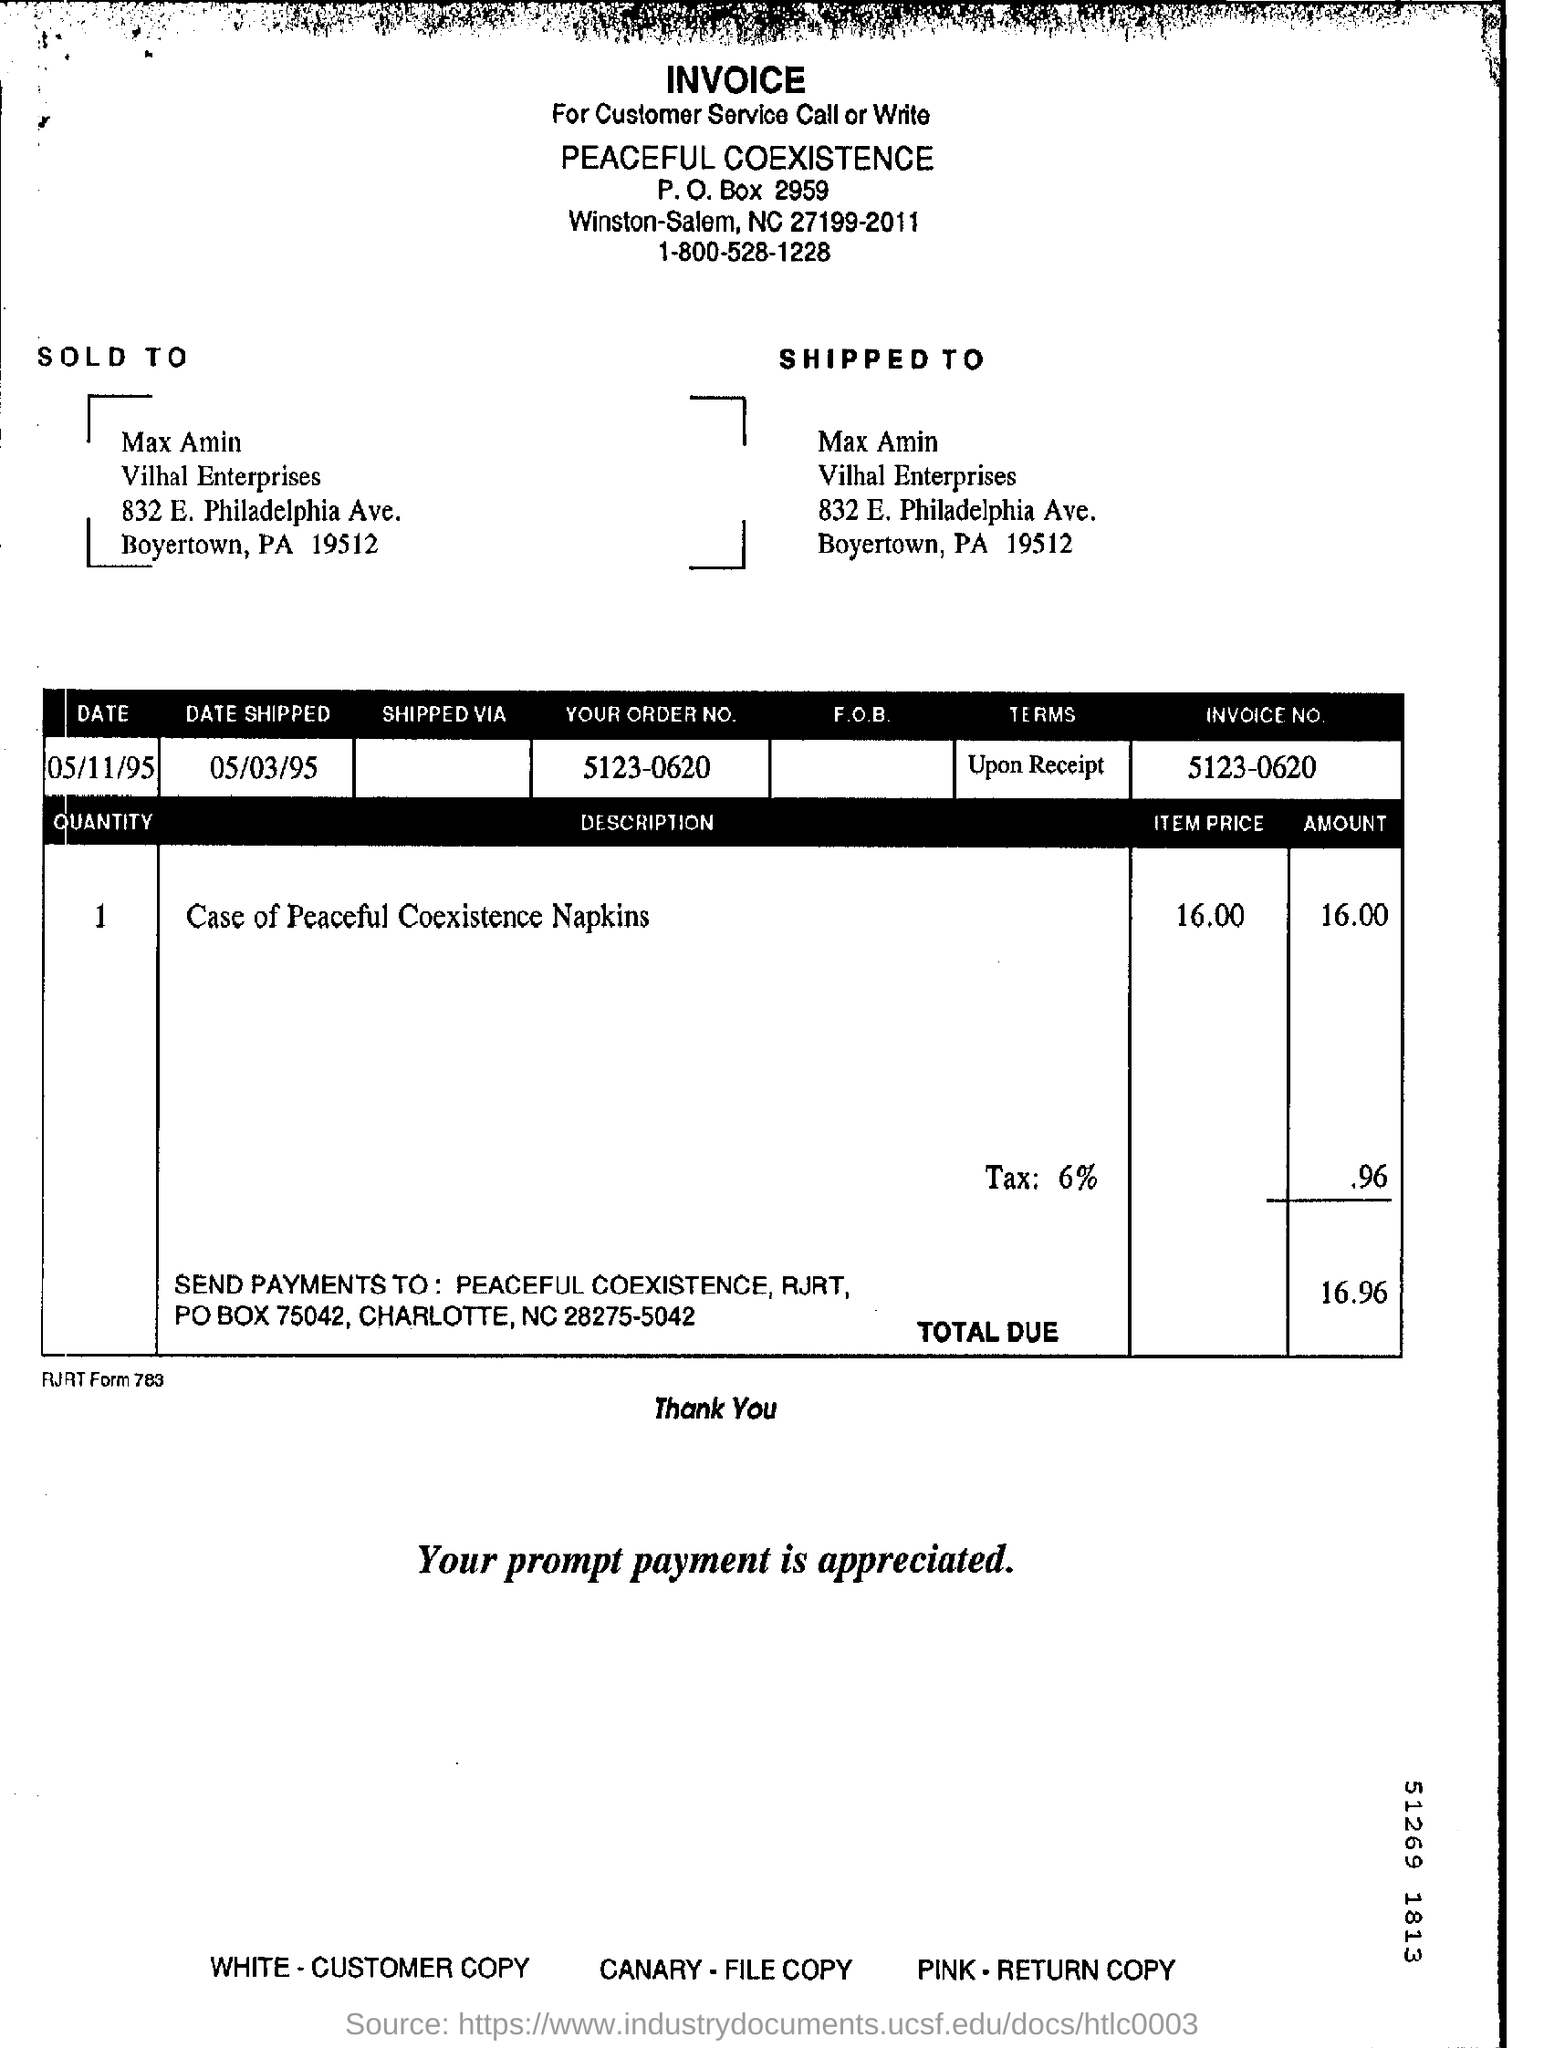What is the Item Price for Case of Peaceful Coexistence Napkins?
Your response must be concise. 16.00. What is the Total Due?
Your answer should be compact. 16.96. What is the Invoice No.?
Your answer should be compact. 5123-0620. What is the "Date Shipped"?
Ensure brevity in your answer.  05/03/95. 